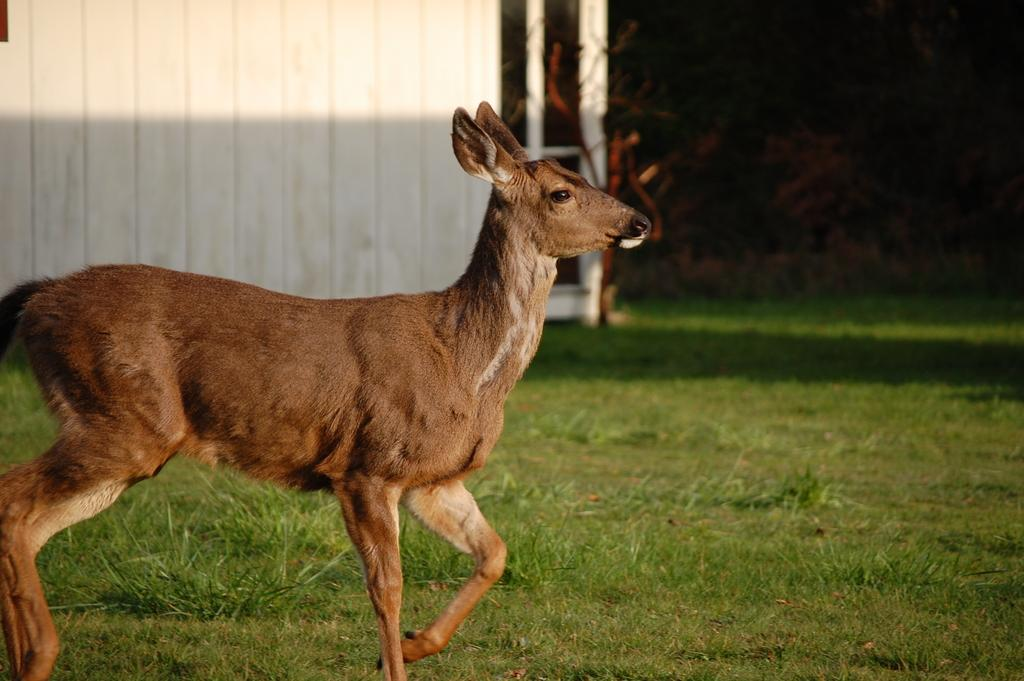What animal can be seen in the image? There is a deer in the image. What is the deer doing in the image? The deer is walking on the grass. What type of vegetation is visible in the background of the image? There are bushes in the background of the image. What kind of structure can be seen in the background of the image? There is a wooden wall in the background of the image. How many companies are mentioned in the image? There are no companies mentioned in the image; it features a deer walking on the grass with a wooden wall and bushes in the background. 